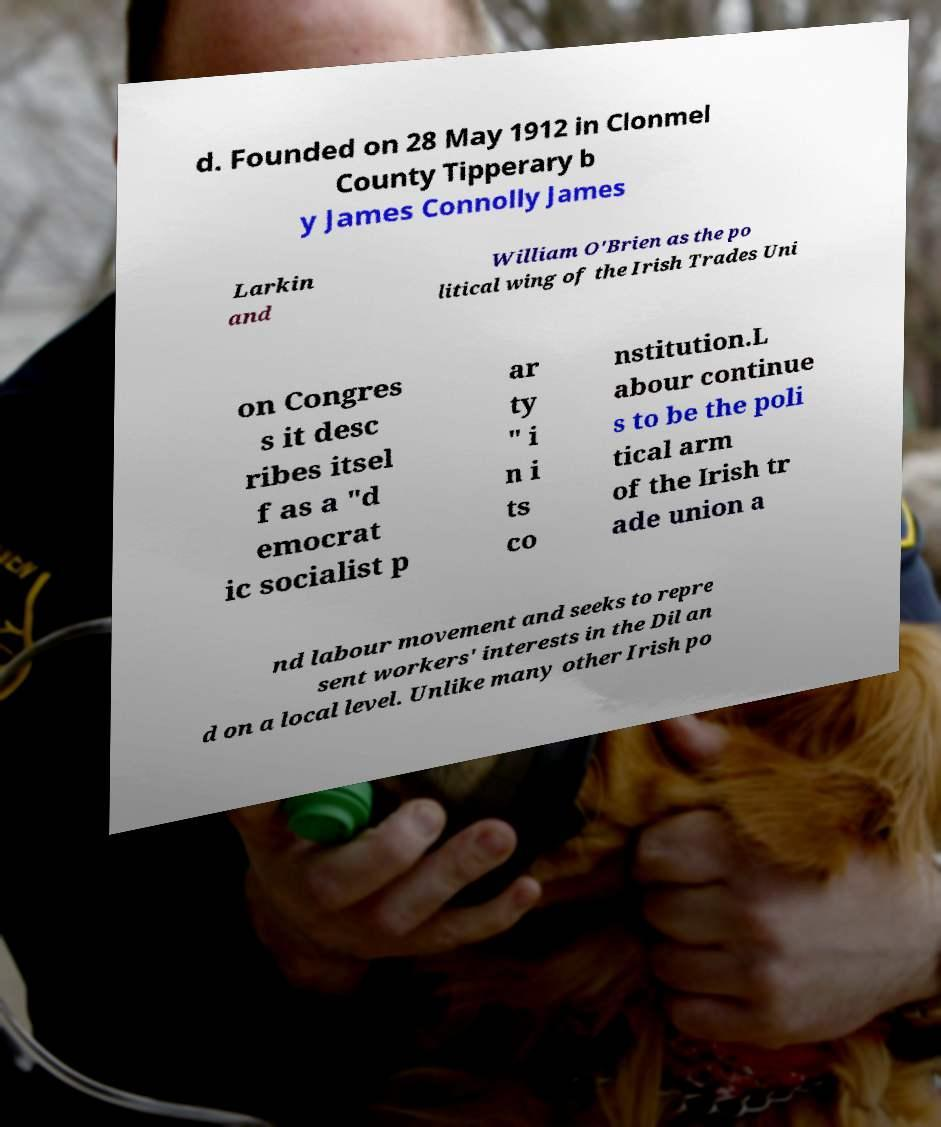Please identify and transcribe the text found in this image. d. Founded on 28 May 1912 in Clonmel County Tipperary b y James Connolly James Larkin and William O'Brien as the po litical wing of the Irish Trades Uni on Congres s it desc ribes itsel f as a "d emocrat ic socialist p ar ty " i n i ts co nstitution.L abour continue s to be the poli tical arm of the Irish tr ade union a nd labour movement and seeks to repre sent workers' interests in the Dil an d on a local level. Unlike many other Irish po 